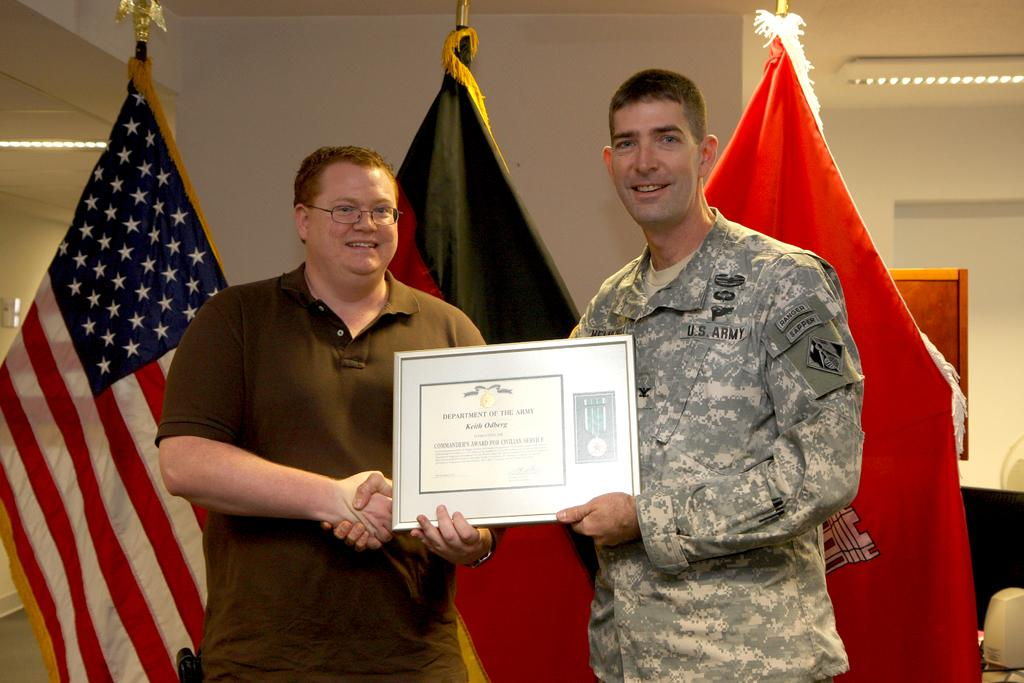How many people are present in the image? There are two people standing in the image. What are the people holding in their hands? Both people are holding an object. What can be seen in the background of the image? There are three flags and a wall visible in the background of the image. What type of dinosaurs can be seen in the image? There are no dinosaurs present in the image. What type of popcorn is being served during the voyage depicted in the image? There is no voyage or popcorn present in the image. 